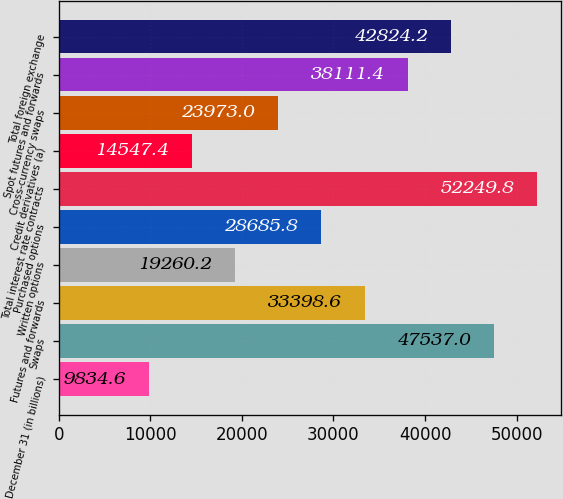<chart> <loc_0><loc_0><loc_500><loc_500><bar_chart><fcel>December 31 (in billions)<fcel>Swaps<fcel>Futures and forwards<fcel>Written options<fcel>Purchased options<fcel>Total interest rate contracts<fcel>Credit derivatives (a)<fcel>Cross-currency swaps<fcel>Spot futures and forwards<fcel>Total foreign exchange<nl><fcel>9834.6<fcel>47537<fcel>33398.6<fcel>19260.2<fcel>28685.8<fcel>52249.8<fcel>14547.4<fcel>23973<fcel>38111.4<fcel>42824.2<nl></chart> 